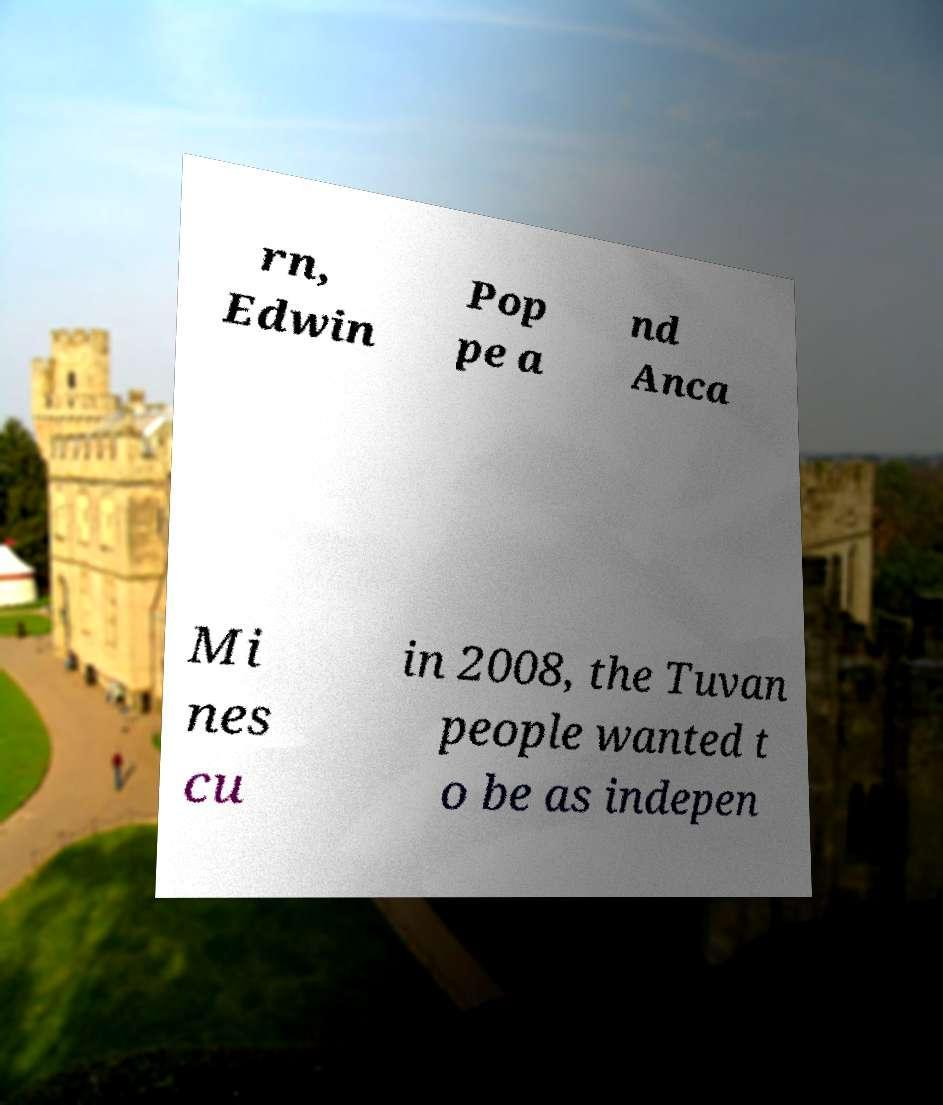What messages or text are displayed in this image? I need them in a readable, typed format. rn, Edwin Pop pe a nd Anca Mi nes cu in 2008, the Tuvan people wanted t o be as indepen 